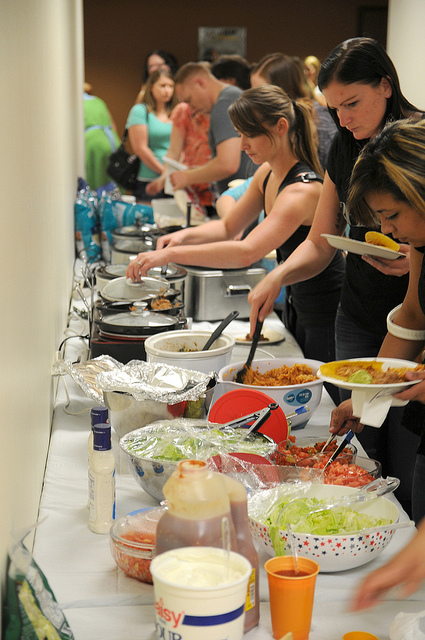Can you identify what type of event this might be? Based on the image, this looks like a communal gathering, possibly a potluck or a buffet-style meal, where people bring different dishes to share. The setup is informal, indicative of a social event such as a community meal, a workplace luncheon, or a family celebration. 